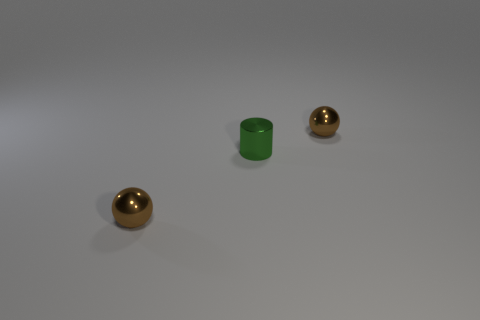Can you describe the lighting in the scene? The scene is lit from above as indicated by the soft shadows projected directly underneath the objects. The lighting appears diffused, creating gentle shading on the surfaces without harsh contrasts. 